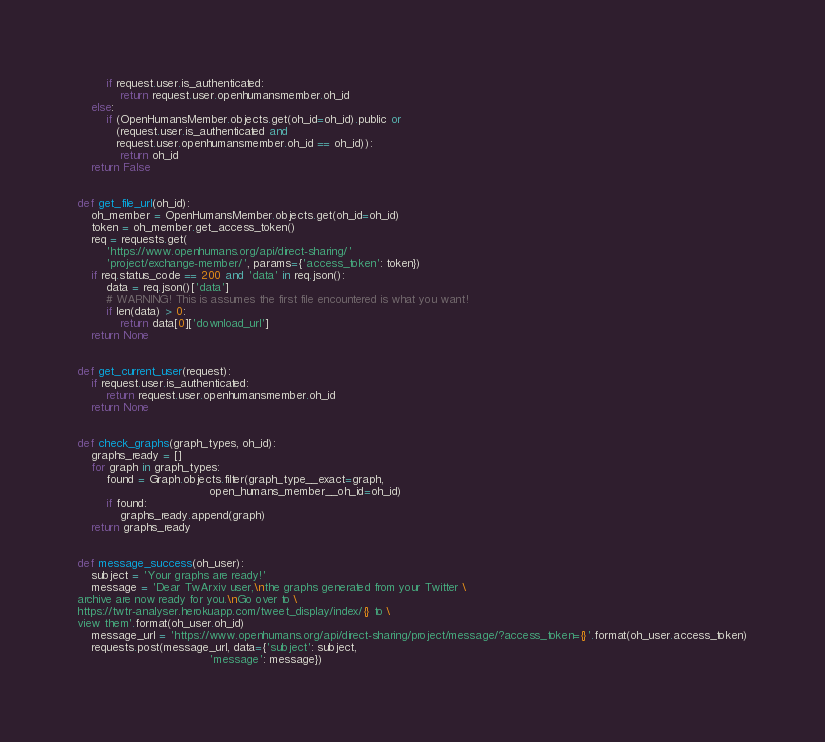<code> <loc_0><loc_0><loc_500><loc_500><_Python_>        if request.user.is_authenticated:
            return request.user.openhumansmember.oh_id
    else:
        if (OpenHumansMember.objects.get(oh_id=oh_id).public or
           (request.user.is_authenticated and
           request.user.openhumansmember.oh_id == oh_id)):
            return oh_id
    return False


def get_file_url(oh_id):
    oh_member = OpenHumansMember.objects.get(oh_id=oh_id)
    token = oh_member.get_access_token()
    req = requests.get(
        'https://www.openhumans.org/api/direct-sharing/'
        'project/exchange-member/', params={'access_token': token})
    if req.status_code == 200 and 'data' in req.json():
        data = req.json()['data']
        # WARNING! This is assumes the first file encountered is what you want!
        if len(data) > 0:
            return data[0]['download_url']
    return None


def get_current_user(request):
    if request.user.is_authenticated:
        return request.user.openhumansmember.oh_id
    return None


def check_graphs(graph_types, oh_id):
    graphs_ready = []
    for graph in graph_types:
        found = Graph.objects.filter(graph_type__exact=graph,
                                     open_humans_member__oh_id=oh_id)
        if found:
            graphs_ready.append(graph)
    return graphs_ready


def message_success(oh_user):
    subject = 'Your graphs are ready!'
    message = 'Dear TwArxiv user,\nthe graphs generated from your Twitter \
archive are now ready for you.\nGo over to \
https://twtr-analyser.herokuapp.com/tweet_display/index/{} to \
view them'.format(oh_user.oh_id)
    message_url = 'https://www.openhumans.org/api/direct-sharing/project/message/?access_token={}'.format(oh_user.access_token)
    requests.post(message_url, data={'subject': subject,
                                     'message': message})
</code> 